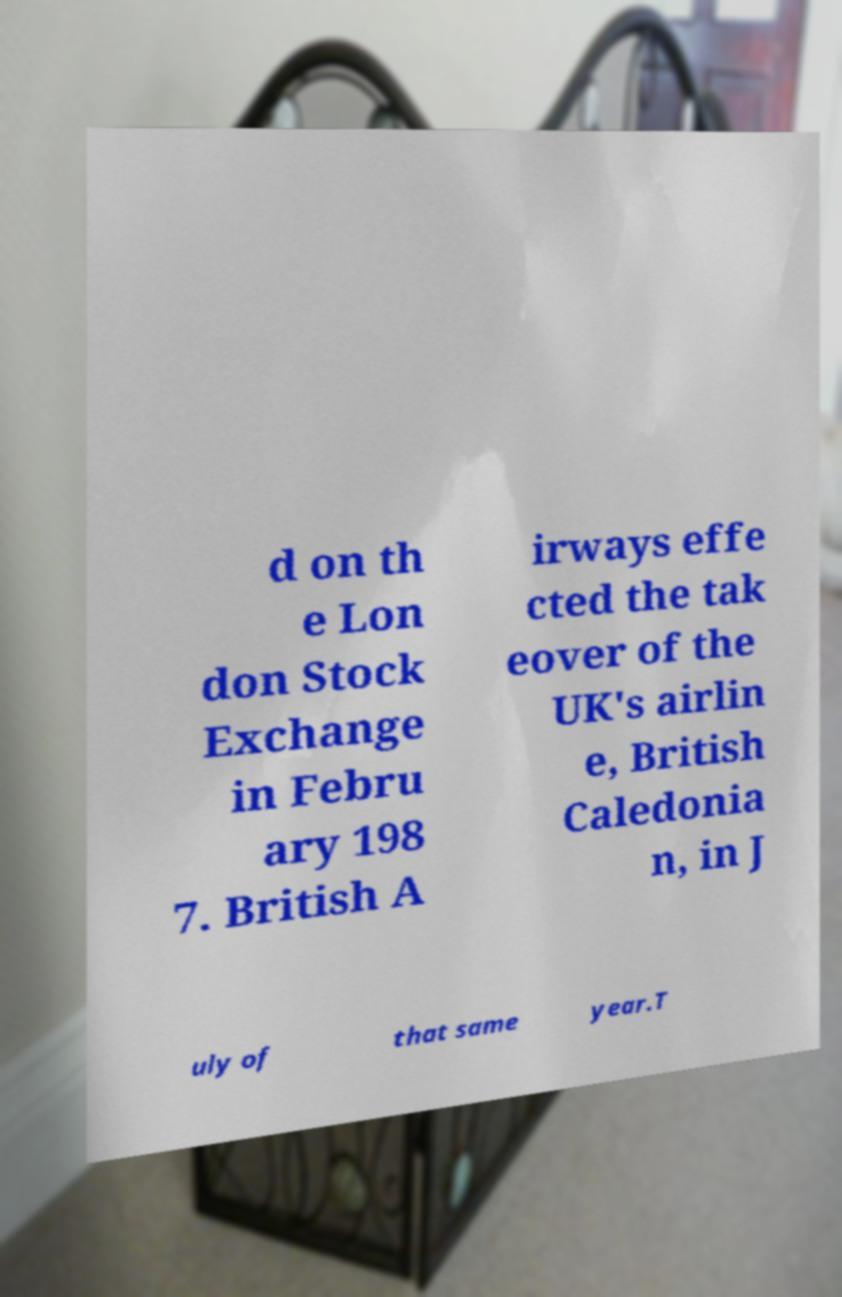For documentation purposes, I need the text within this image transcribed. Could you provide that? d on th e Lon don Stock Exchange in Febru ary 198 7. British A irways effe cted the tak eover of the UK's airlin e, British Caledonia n, in J uly of that same year.T 